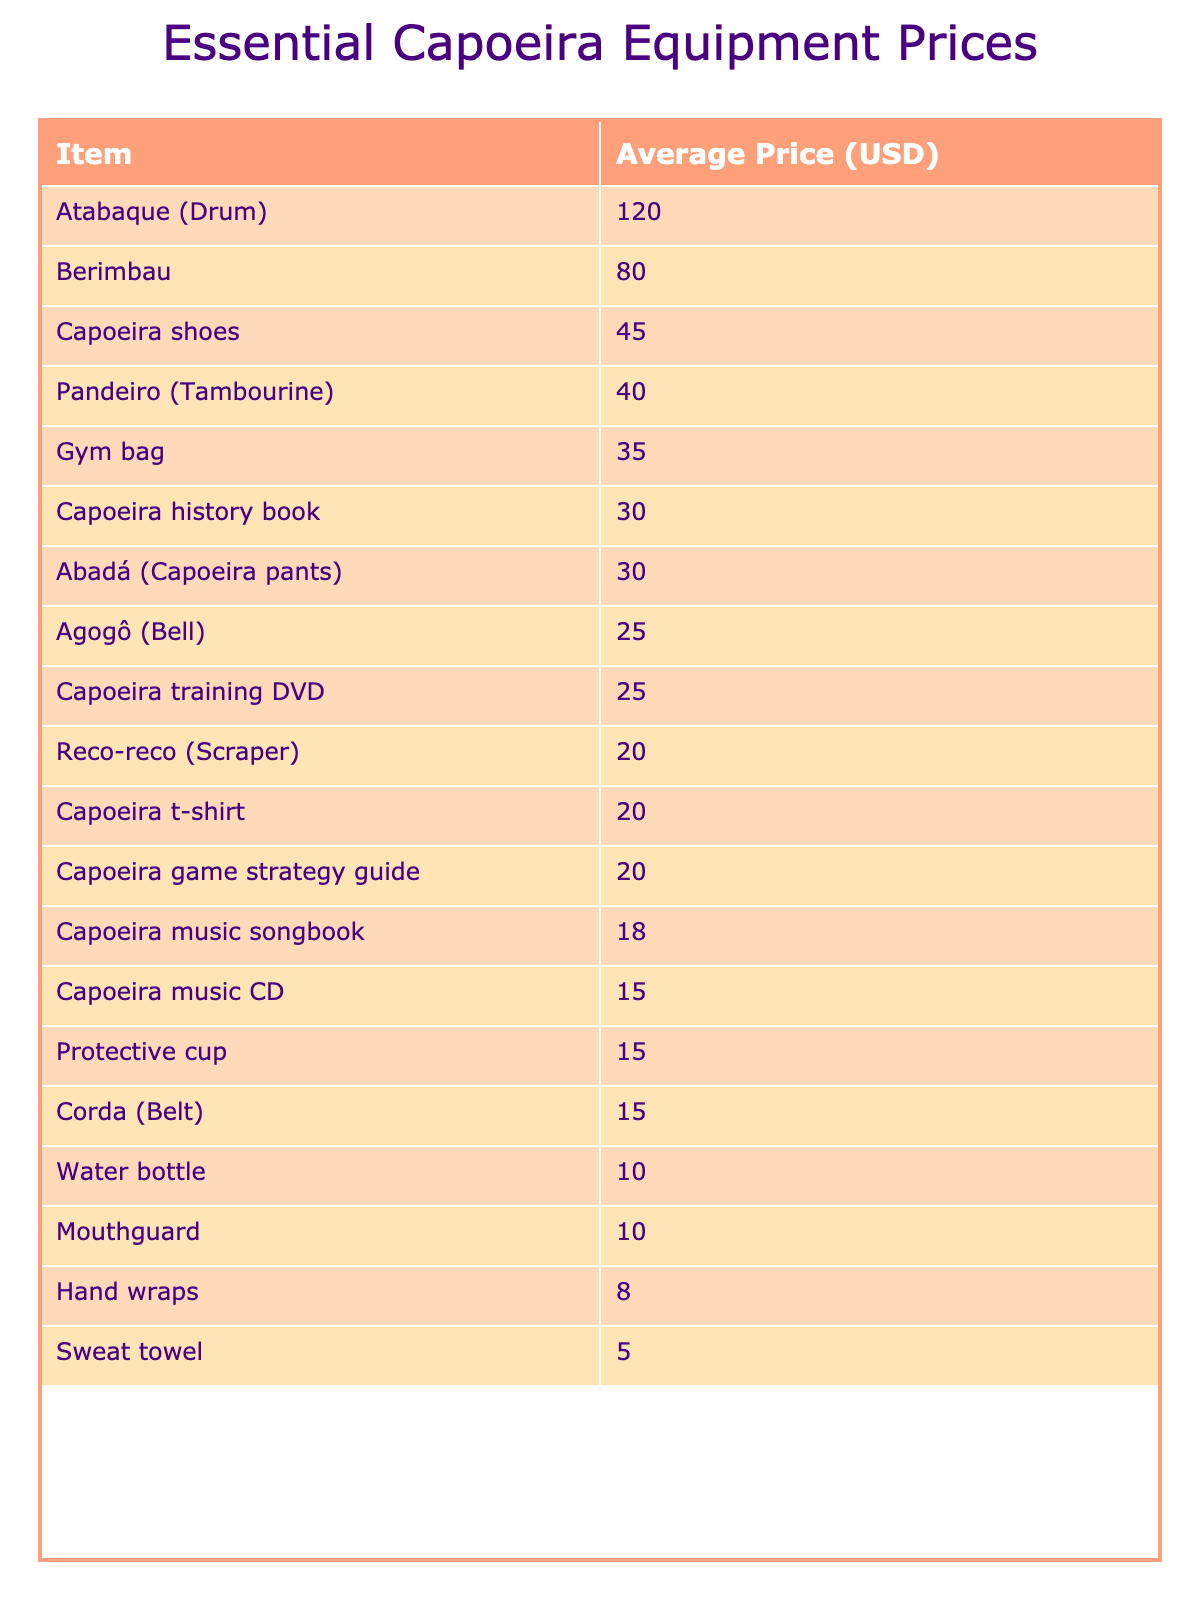What is the average price of a berimbau? The average price of a berimbau is listed in the table, which shows that it is $80.
Answer: $80 What item has the lowest average price? Looking through the table, the item with the lowest average price is the hand wraps, which are priced at $8.
Answer: $8 How much more expensive is an atabaque compared to a pandeiro? The atabaque is priced at $120, while the pandeiro is $40. The difference is calculated as $120 - $40 = $80.
Answer: $80 What is the total cost of buying a capoeira t-shirt, mouthguard, and water bottle? The average prices are $20 for the t-shirt, $10 for the mouthguard, and $10 for the water bottle. Summing these gives $20 + $10 + $10 = $40.
Answer: $40 Is the average price of a capoeira training DVD more than $20? The table shows that the average price of a capoeira training DVD is $25, which is greater than $20.
Answer: Yes What is the combined average price of a capoeira game strategy guide and a capoeira history book? The capoeira game strategy guide costs $20 and the history book costs $30. Adding these together gives $20 + $30 = $50.
Answer: $50 How many items have an average price above $40? The table lists seven items with prices above $40: atabaque, berimbau, capoeira shoes, and pandeiro. Hence, the total count is 4.
Answer: 4 What is the average price of all the items in the table? To find the average price, we sum all the average prices, which gives $30 + $45 + $15 + $80 + $40 + $120 + $25 + $20 + $20 + $15 + $10 + $8 + $15 + $25 + $30 + $20 + $18 + $5 + $10 + $35 = $500. There are 20 items, so the average is $500/20 = $25.
Answer: $25 Which item is more expensive, a gym bag or a berimbau? The gym bag costs $35, while the berimbau costs $80. Since $80 is greater than $35, the berimbau is more expensive.
Answer: Berimbau Are capoeira shoes cheaper than an atabaque? The capoeira shoes cost $45 and the atabaque costs $120. Since $45 is less than $120, the capoeira shoes are indeed cheaper.
Answer: Yes 